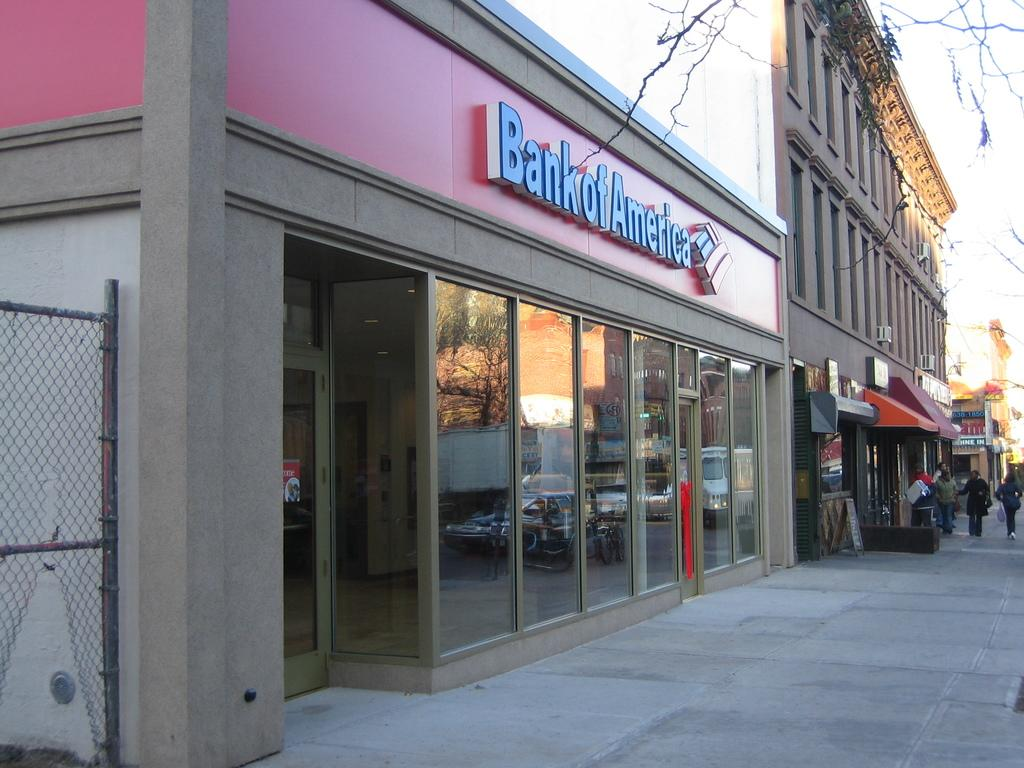<image>
Give a short and clear explanation of the subsequent image. A big building of Bank of America is on the left with some people walking on the pavement. 